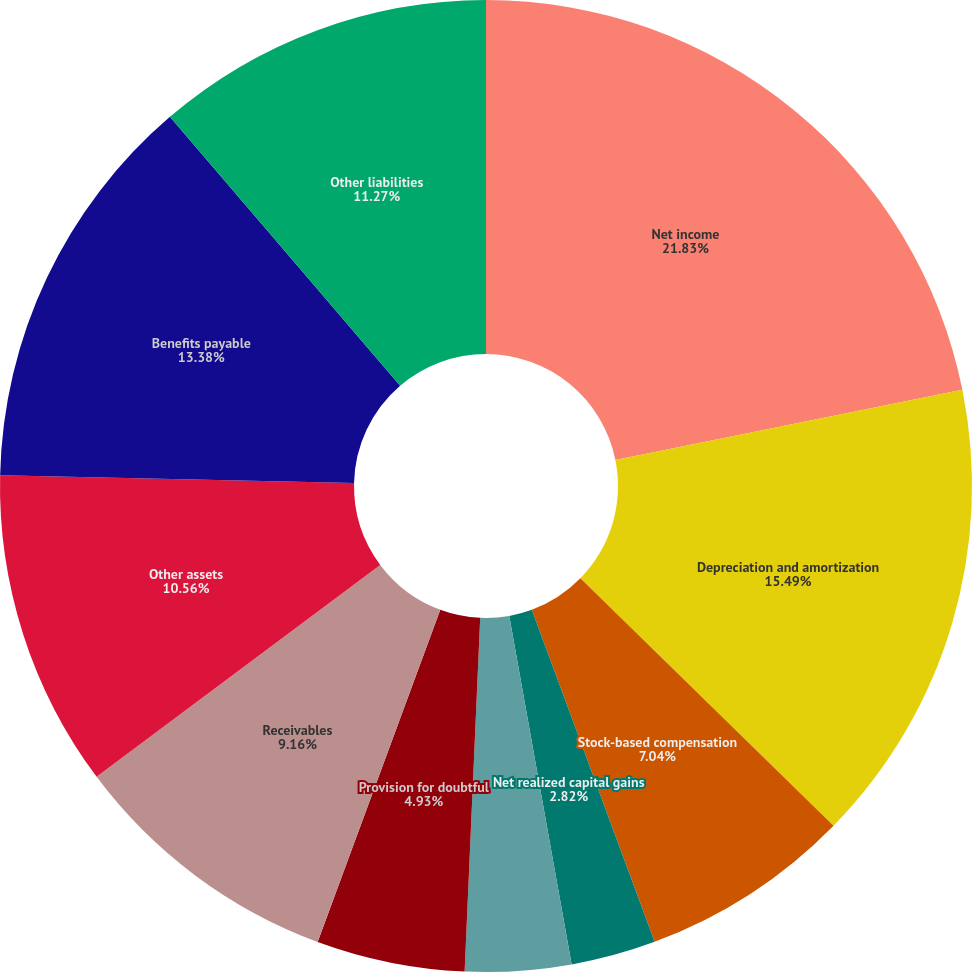Convert chart. <chart><loc_0><loc_0><loc_500><loc_500><pie_chart><fcel>Net income<fcel>Depreciation and amortization<fcel>Stock-based compensation<fcel>Net realized capital gains<fcel>Provision (benefit) for<fcel>Provision for doubtful<fcel>Receivables<fcel>Other assets<fcel>Benefits payable<fcel>Other liabilities<nl><fcel>21.83%<fcel>15.49%<fcel>7.04%<fcel>2.82%<fcel>3.52%<fcel>4.93%<fcel>9.16%<fcel>10.56%<fcel>13.38%<fcel>11.27%<nl></chart> 